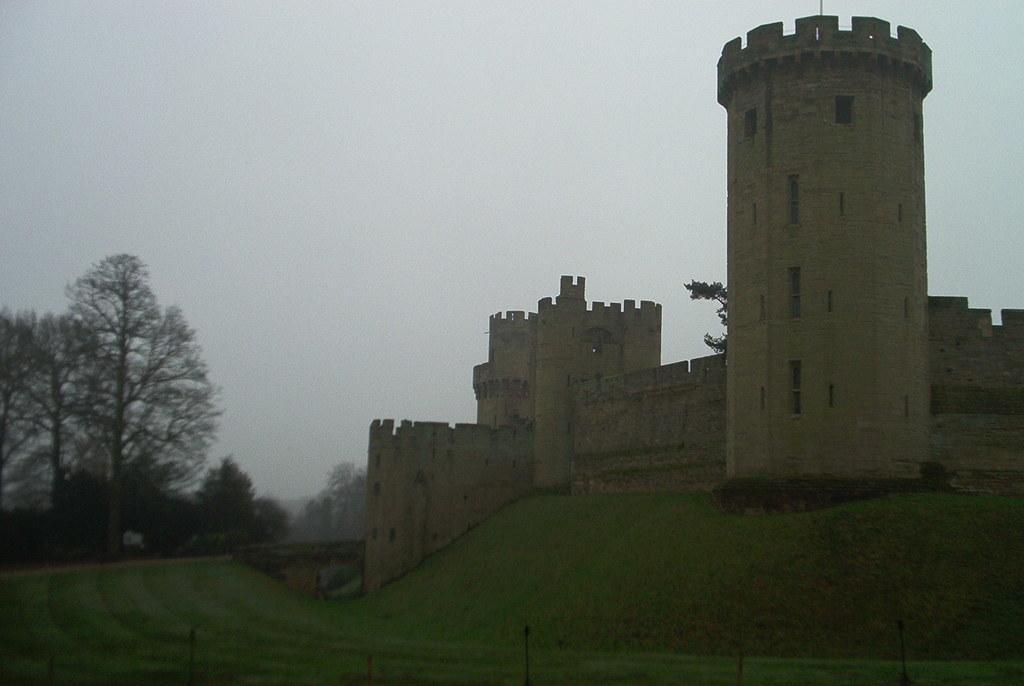How would you summarize this image in a sentence or two? In this image, we can see a castle. There are some trees on the left side of the image. In the background of the image, there is a sky. 